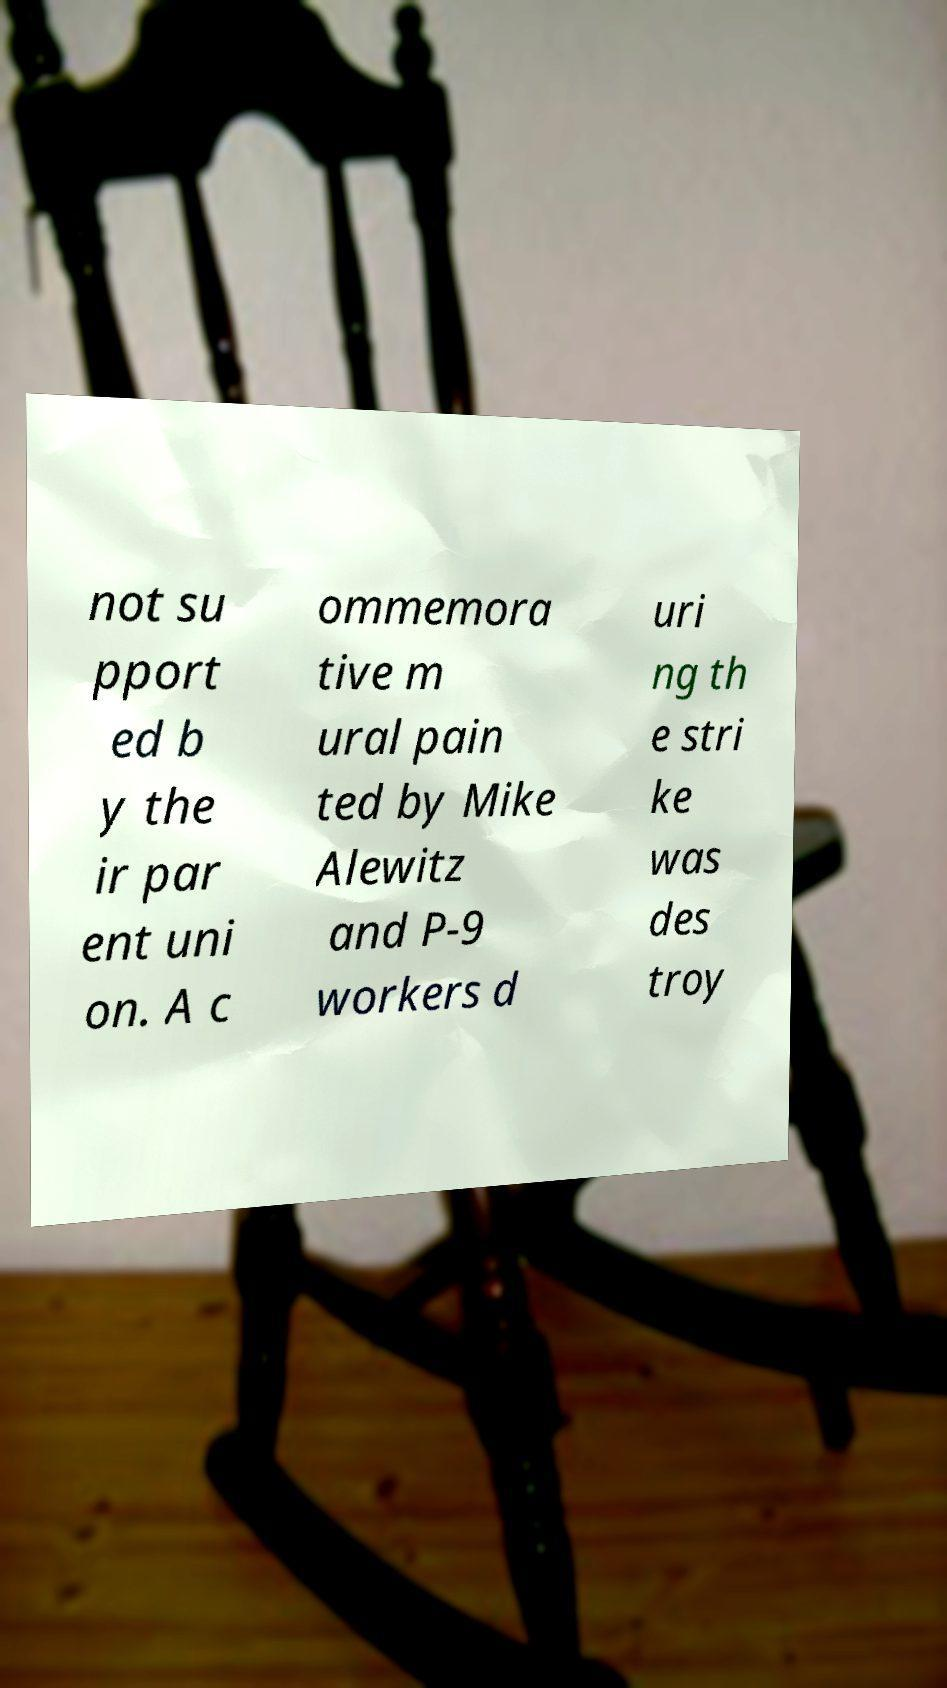Can you accurately transcribe the text from the provided image for me? not su pport ed b y the ir par ent uni on. A c ommemora tive m ural pain ted by Mike Alewitz and P-9 workers d uri ng th e stri ke was des troy 